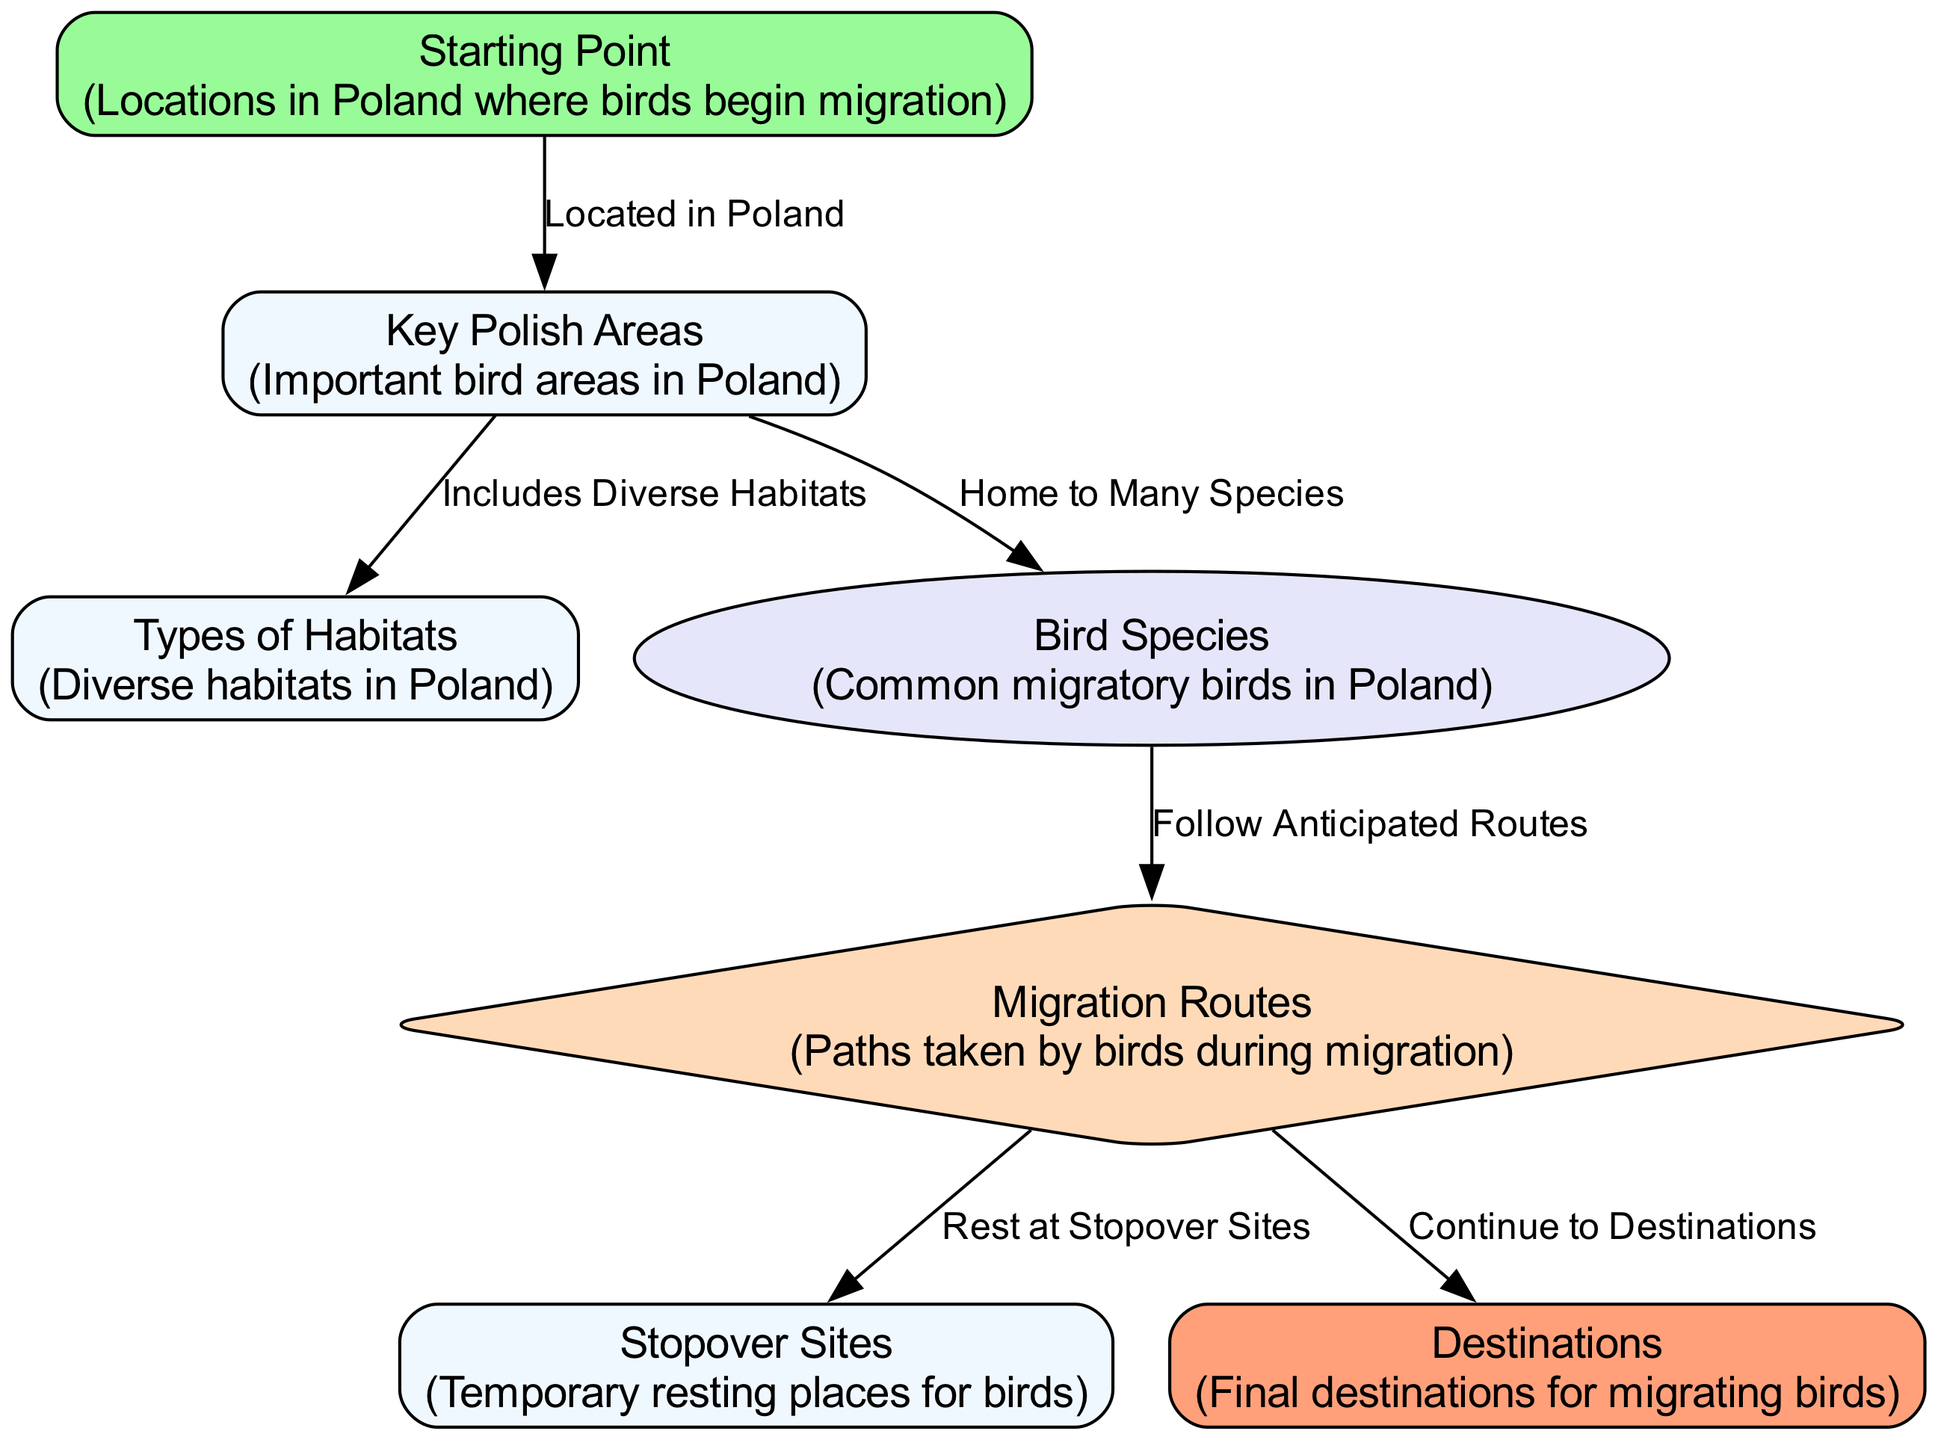What are the starting points of migratory birds in Poland? The diagram specifies "Starting Point" as the initial locations where birds begin their migration in Poland.
Answer: Starting Point How many key Polish areas are indicated in the diagram? The diagram identifies one node labeled "Key Polish Areas," which suggests there is one main area highlighted in the context of bird migration.
Answer: One What do the key Polish areas include? According to the diagram, the key Polish areas "Include Diverse Habitats" which are essential for the birds during migration.
Answer: Diverse Habitats Which bird species follow anticipated routes? The diagram indicates that the bird species node connects to the routes node, affirming that the "Bird Species" follow "Anticipated Routes."
Answer: Bird Species From "routes," where do the birds continue to? The diagram shows that from the "routes" node, the connection leads to the "destinations" node, indicating that birds continue their migration towards specific destinations.
Answer: Destinations What factor influences the choice of stopover sites? The edge from "routes" to "stopover sites" indicates that birds "Rest at Stopover Sites," implying that the chosen routes heavily influence where birds stop to rest.
Answer: Routes Which type of diagram is used to represent migration patterns? The diagram type specified is a "Textbook Diagram," which is particularly informative and relates to educational purposes in illustrating various elements involved in bird migration.
Answer: Textbook Diagram What is the relationship between species and habitats? The diagram connects "Key Polish Areas" to both "Bird Species" and "Types of Habitats," establishing that the key areas "Home to Many Species" are directly associated with the "Diverse Habitats" they provide.
Answer: Home to Many Species How many edges are represented in the migration diagram? The diagram shows a total of six edges connecting various nodes, highlighting the pathways and relationships among starting points, key areas, species, routes, stopover sites, and destinations.
Answer: Six 